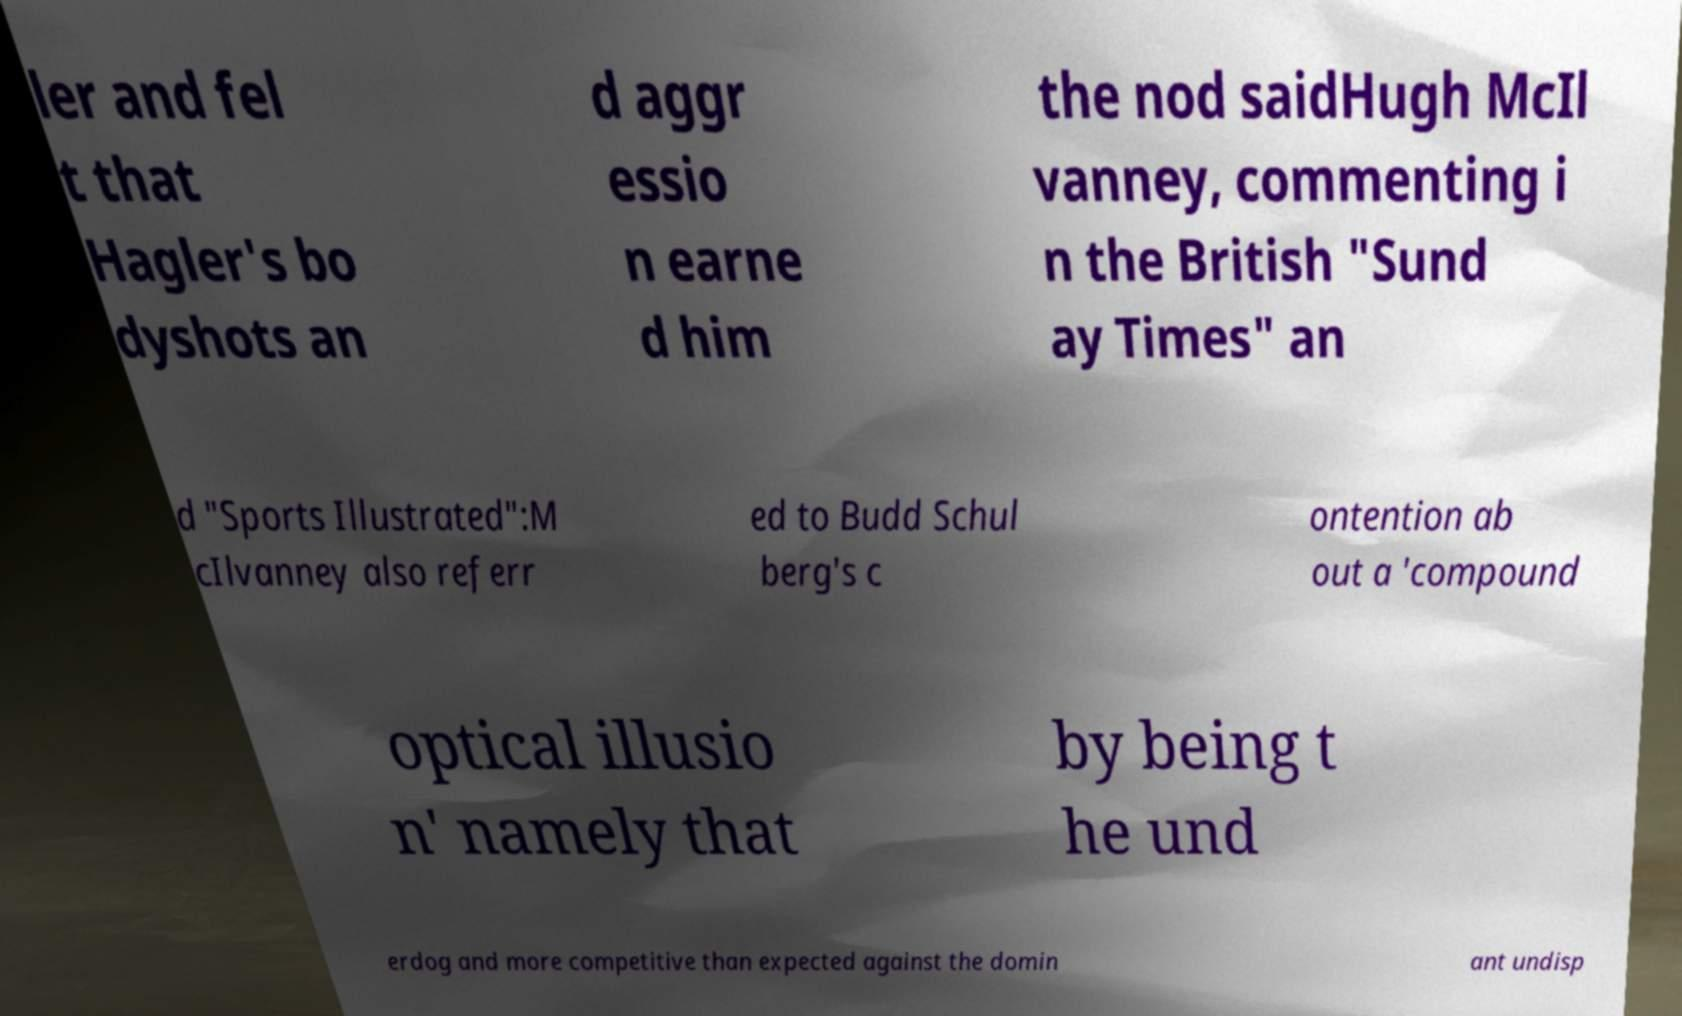Can you read and provide the text displayed in the image?This photo seems to have some interesting text. Can you extract and type it out for me? ler and fel t that Hagler's bo dyshots an d aggr essio n earne d him the nod saidHugh McIl vanney, commenting i n the British "Sund ay Times" an d "Sports Illustrated":M cIlvanney also referr ed to Budd Schul berg's c ontention ab out a 'compound optical illusio n' namely that by being t he und erdog and more competitive than expected against the domin ant undisp 